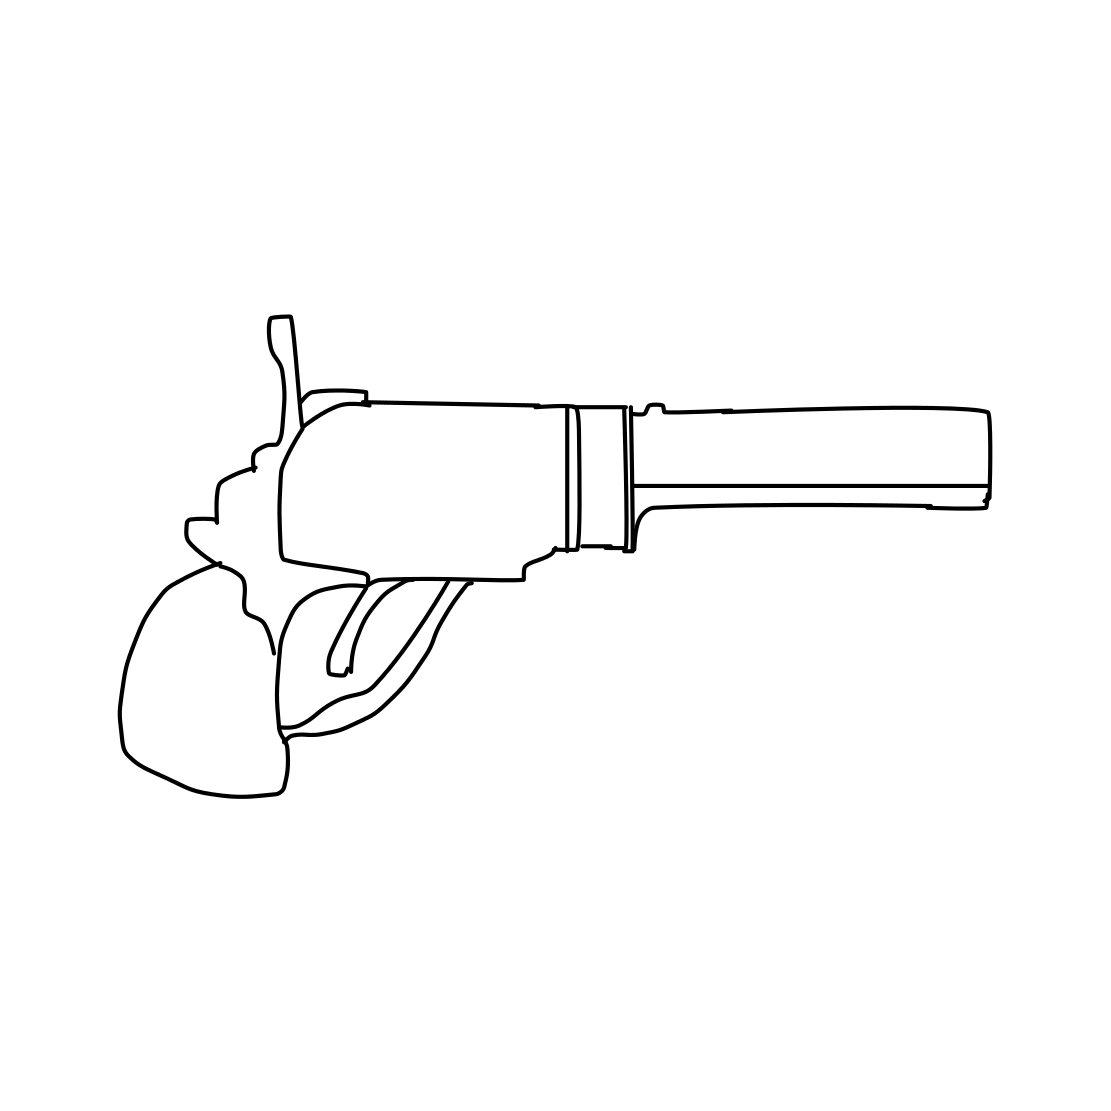Could this illustration be symbolic in any way? Yes, in a symbolic context, the revolver sketch could represent themes such as justice or personal protection, or alternatively it could symbolize violence and danger. The interpretation would depend heavily on the context in which the image is used. 